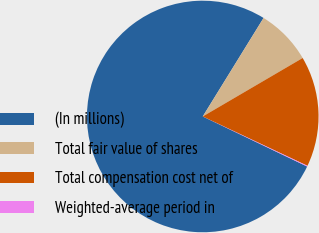Convert chart to OTSL. <chart><loc_0><loc_0><loc_500><loc_500><pie_chart><fcel>(In millions)<fcel>Total fair value of shares<fcel>Total compensation cost net of<fcel>Weighted-average period in<nl><fcel>76.68%<fcel>7.77%<fcel>15.43%<fcel>0.11%<nl></chart> 